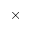Convert formula to latex. <formula><loc_0><loc_0><loc_500><loc_500>\times</formula> 